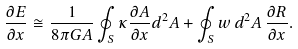<formula> <loc_0><loc_0><loc_500><loc_500>\frac { \partial E } { \partial x } \cong \frac { 1 } { 8 \pi G A } \oint _ { S } \kappa \frac { \partial A } { \partial x } d ^ { 2 } A + \oint _ { S } w \, d ^ { 2 } A \, \frac { \partial R } { \partial x } .</formula> 